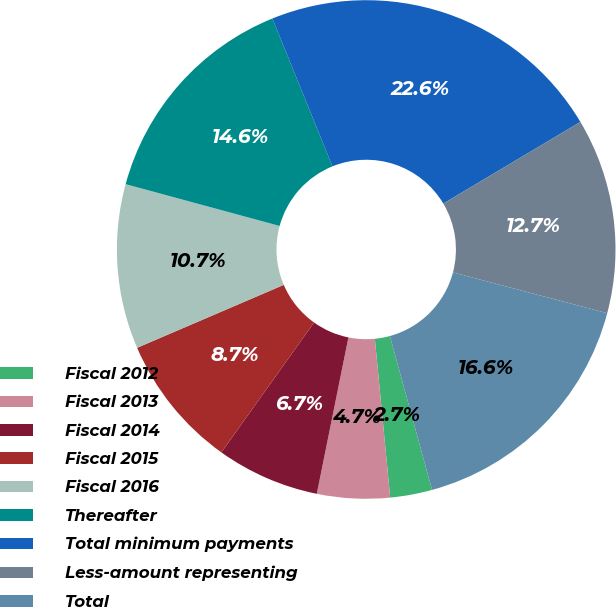<chart> <loc_0><loc_0><loc_500><loc_500><pie_chart><fcel>Fiscal 2012<fcel>Fiscal 2013<fcel>Fiscal 2014<fcel>Fiscal 2015<fcel>Fiscal 2016<fcel>Thereafter<fcel>Total minimum payments<fcel>Less-amount representing<fcel>Total<nl><fcel>2.72%<fcel>4.71%<fcel>6.69%<fcel>8.68%<fcel>10.67%<fcel>14.64%<fcel>22.59%<fcel>12.66%<fcel>16.63%<nl></chart> 